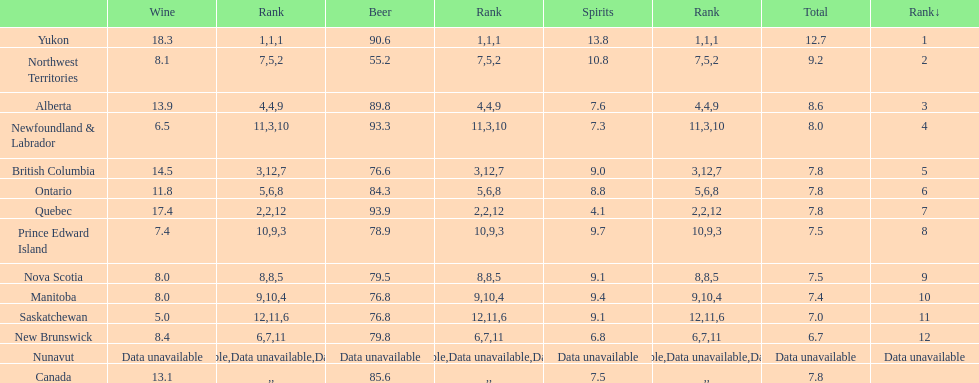In terms of beer drinking, was quebec or northwest territories the leader? Quebec. 